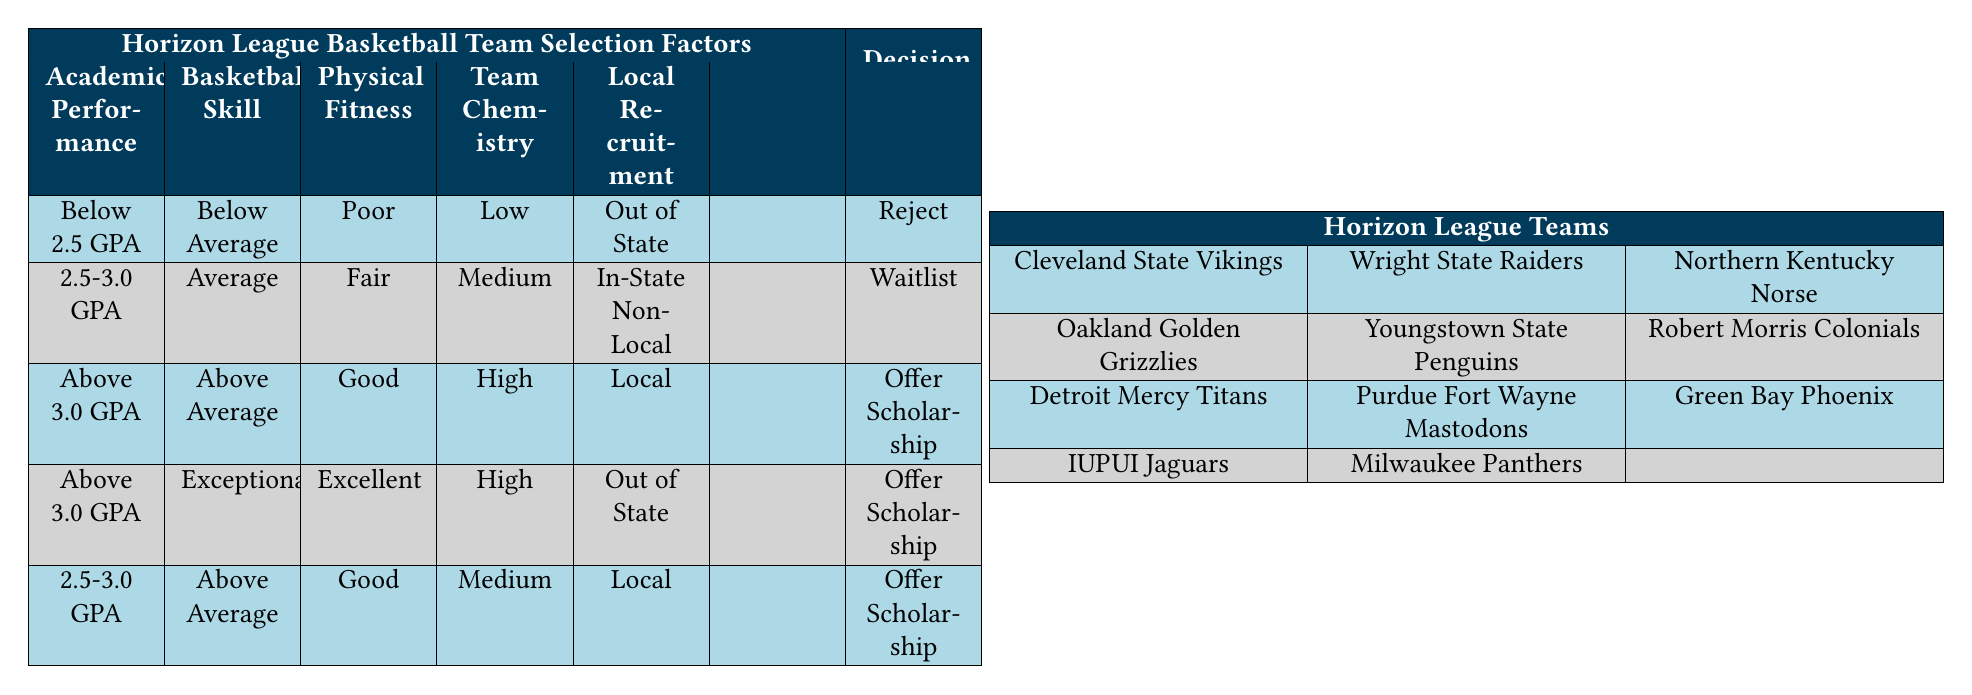What happens to a player with an academic performance below 2.5 GPA and poor physical fitness? According to the table, if a player has a GPA below 2.5 and is categorized as having poor physical fitness, their decision would be to "Reject." This is based on the first rule listed in the rules section.
Answer: Reject Under what conditions would a player be waitlisted? A player would be waitlisted if they have a GPA between 2.5-3.0, are categorized as average in basketball skill, have fair physical fitness, possess medium team chemistry, and are from in-state non-local recruitment. This is outlined in the second rule of the table.
Answer: 2.5-3.0 GPA, Average, Fair, Medium, In-State Non-Local Do players who score above average in basketball skill automatically receive scholarship offers? No, players scoring above average in basketball skill do not automatically receive scholarship offers; it depends on their GPA, physical fitness, team chemistry, and local recruitment. For example, only players with above 3.0 GPA and good physical fitness from local recruitment receive offers.
Answer: No What is the relationship between team chemistry and scholarship offers based on the table? The table indicates that "High" team chemistry is a key factor for receiving offers, especially when combined with a GPA above 3.0 and good physical fitness. In contrast, "Low" team chemistry is part of the condition that leads to rejection, demonstrating that team chemistry plays a critical role.
Answer: High team chemistry leads to offers, low leads to rejection Which academic performance level has the potential for an offer based on the condition of being local? According to the table, players with above 3.0 GPA or those with a GPA between 2.5-3.0 and above average skill level can receive offers if they are also local. This indicates that being local enhances the chances of receiving offers, given good academic performance.
Answer: Above 3.0 GPA or 2.5-3.0 GPA with above average skill How many total conditions are outlined for making a team selection decision? There are five conditions outlined for making a team selection decision: Academic Performance, Basketball Skill Level, Physical Fitness, Team Chemistry, and Local Recruitment. Counting these, we find there are a total of 5 conditions.
Answer: 5 conditions Is there a scholarship offer available for exceptional players with a GPA above 3.0 and local recruitment? Yes, the table specifies that players categorized as exceptional, with above 3.0 GPA and excellent physical fitness from out of state, will receive an offer. Therefore, exceptional players still have an opportunity to receive an offer under these conditions.
Answer: Yes If a player is in-state non-local, can they still receive an offer? Yes, they can receive an offer if they have a GPA between 2.5-3.0 and are categorized as above average in skill, have good physical fitness, and possess medium team chemistry. Therefore, in-state non-local players can still qualify for offers under specific conditions.
Answer: Yes 